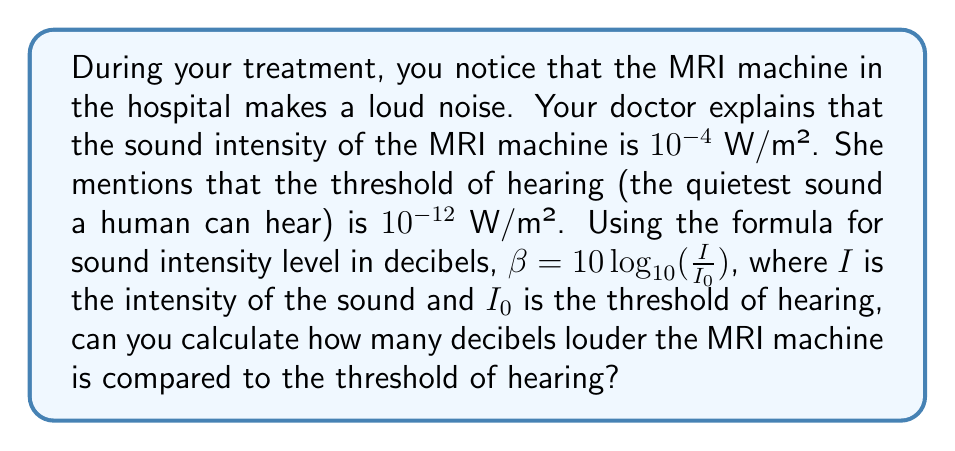Can you answer this question? Let's approach this step-by-step:

1) We are given:
   - The intensity of the MRI machine, $I = 10^{-4}$ W/m²
   - The threshold of hearing, $I_0 = 10^{-12}$ W/m²
   - The formula: $\beta = 10 \log_{10}(\frac{I}{I_0})$

2) Let's substitute our values into the formula:

   $\beta = 10 \log_{10}(\frac{10^{-4}}{10^{-12}})$

3) Simplify inside the parentheses:

   $\beta = 10 \log_{10}(10^8)$

4) Use the logarithm property $\log_a(x^n) = n\log_a(x)$:

   $\beta = 10 \cdot 8 \log_{10}(10)$

5) $\log_{10}(10) = 1$, so:

   $\beta = 10 \cdot 8 \cdot 1 = 80$

Therefore, the MRI machine is 80 decibels louder than the threshold of hearing.
Answer: 80 decibels 